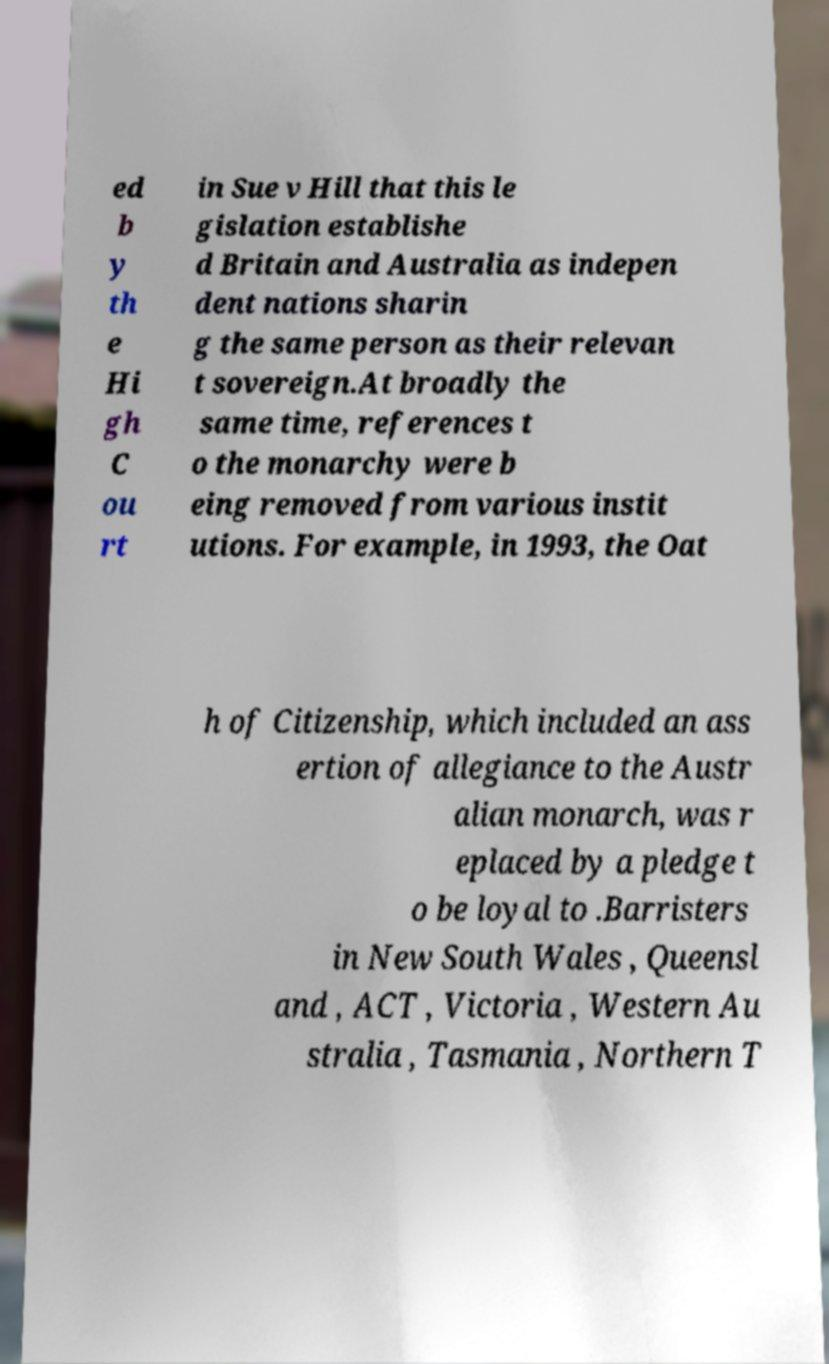Can you read and provide the text displayed in the image?This photo seems to have some interesting text. Can you extract and type it out for me? ed b y th e Hi gh C ou rt in Sue v Hill that this le gislation establishe d Britain and Australia as indepen dent nations sharin g the same person as their relevan t sovereign.At broadly the same time, references t o the monarchy were b eing removed from various instit utions. For example, in 1993, the Oat h of Citizenship, which included an ass ertion of allegiance to the Austr alian monarch, was r eplaced by a pledge t o be loyal to .Barristers in New South Wales , Queensl and , ACT , Victoria , Western Au stralia , Tasmania , Northern T 